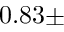<formula> <loc_0><loc_0><loc_500><loc_500>0 . 8 3 \pm</formula> 